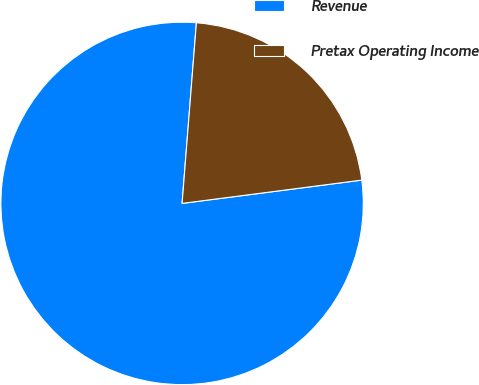Convert chart. <chart><loc_0><loc_0><loc_500><loc_500><pie_chart><fcel>Revenue<fcel>Pretax Operating Income<nl><fcel>78.31%<fcel>21.69%<nl></chart> 